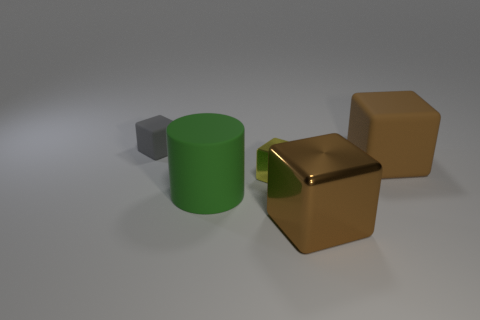Subtract all tiny rubber cubes. How many cubes are left? 3 Subtract all gray cubes. How many cubes are left? 3 Subtract all blocks. How many objects are left? 1 Subtract all cyan cylinders. Subtract all blue balls. How many cylinders are left? 1 Add 4 gray rubber blocks. How many gray rubber blocks are left? 5 Add 4 small yellow balls. How many small yellow balls exist? 4 Add 4 tiny shiny things. How many objects exist? 9 Subtract 0 yellow spheres. How many objects are left? 5 Subtract 1 cylinders. How many cylinders are left? 0 Subtract all yellow blocks. How many brown cylinders are left? 0 